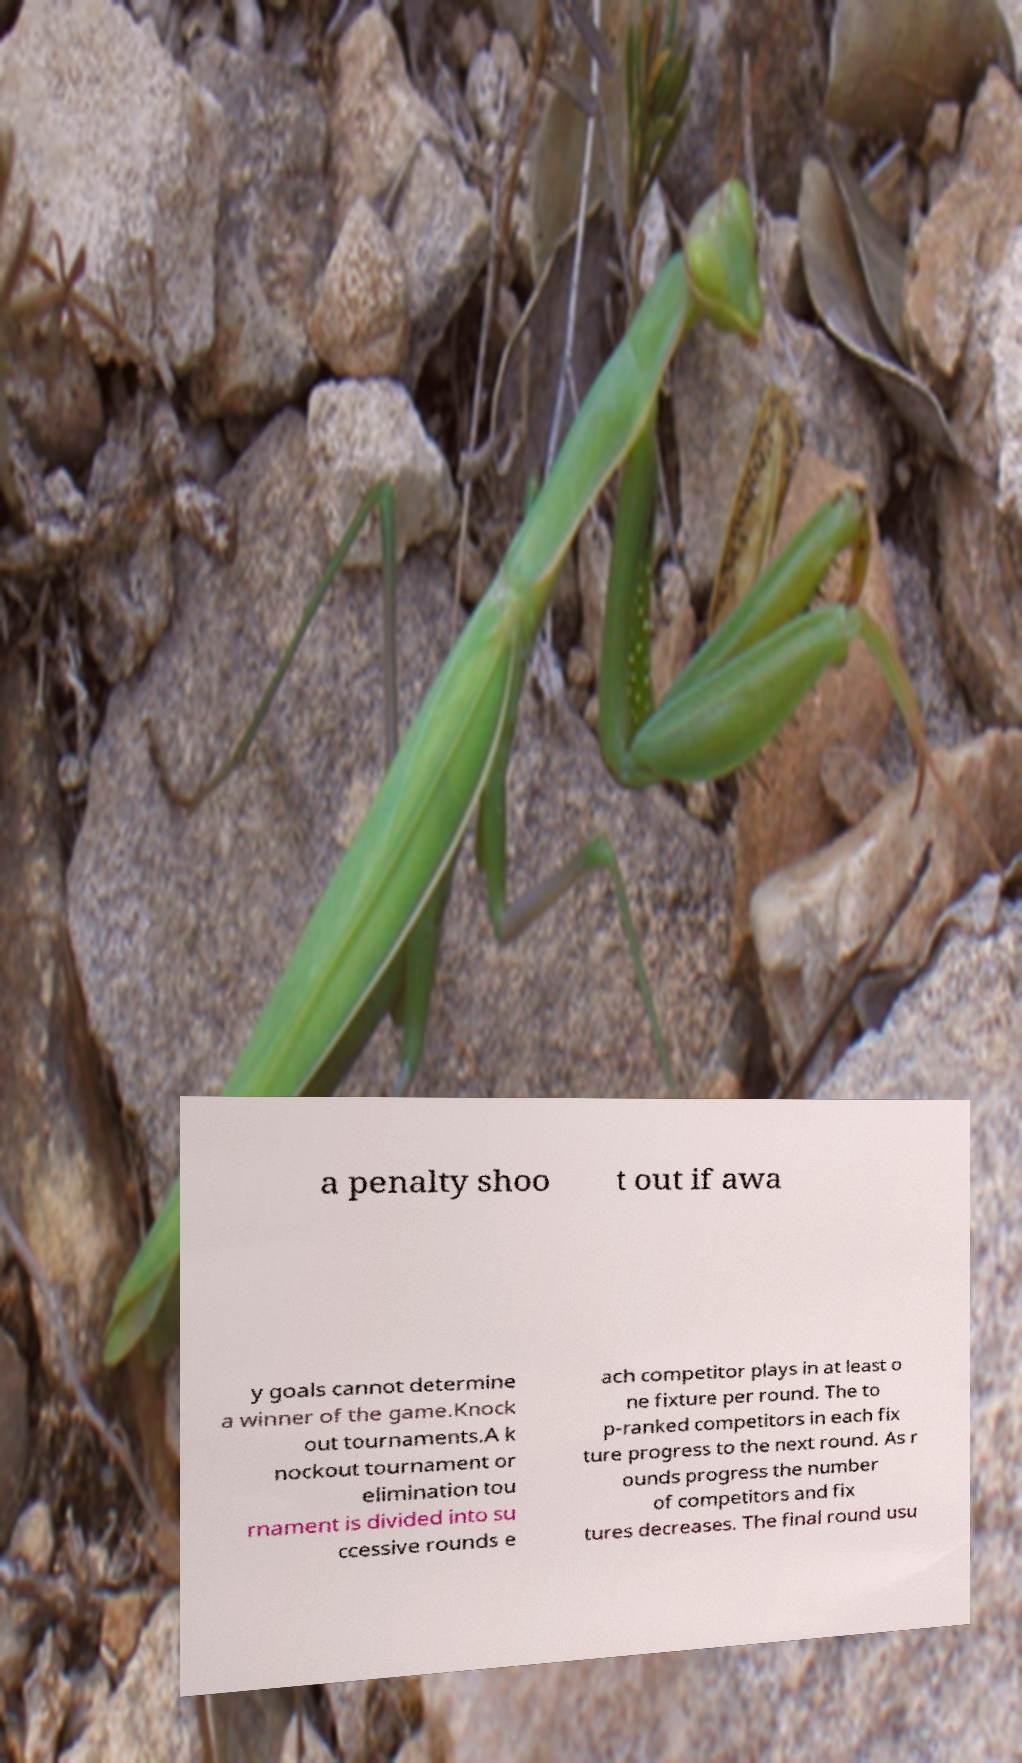There's text embedded in this image that I need extracted. Can you transcribe it verbatim? a penalty shoo t out if awa y goals cannot determine a winner of the game.Knock out tournaments.A k nockout tournament or elimination tou rnament is divided into su ccessive rounds e ach competitor plays in at least o ne fixture per round. The to p-ranked competitors in each fix ture progress to the next round. As r ounds progress the number of competitors and fix tures decreases. The final round usu 